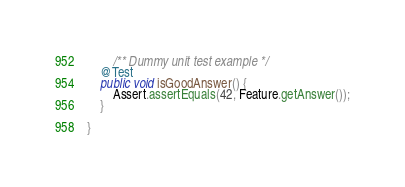<code> <loc_0><loc_0><loc_500><loc_500><_Java_>
        /** Dummy unit test example */
	@Test
	public void isGoodAnswer() {
		Assert.assertEquals(42, Feature.getAnswer());
	}

}
</code> 